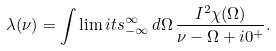<formula> <loc_0><loc_0><loc_500><loc_500>\lambda ( \nu ) = \int \lim i t s ^ { \infty } _ { - \infty } \, d \Omega \, \frac { I ^ { 2 } \chi ( \Omega ) } { \nu - \Omega + i 0 ^ { + } } .</formula> 